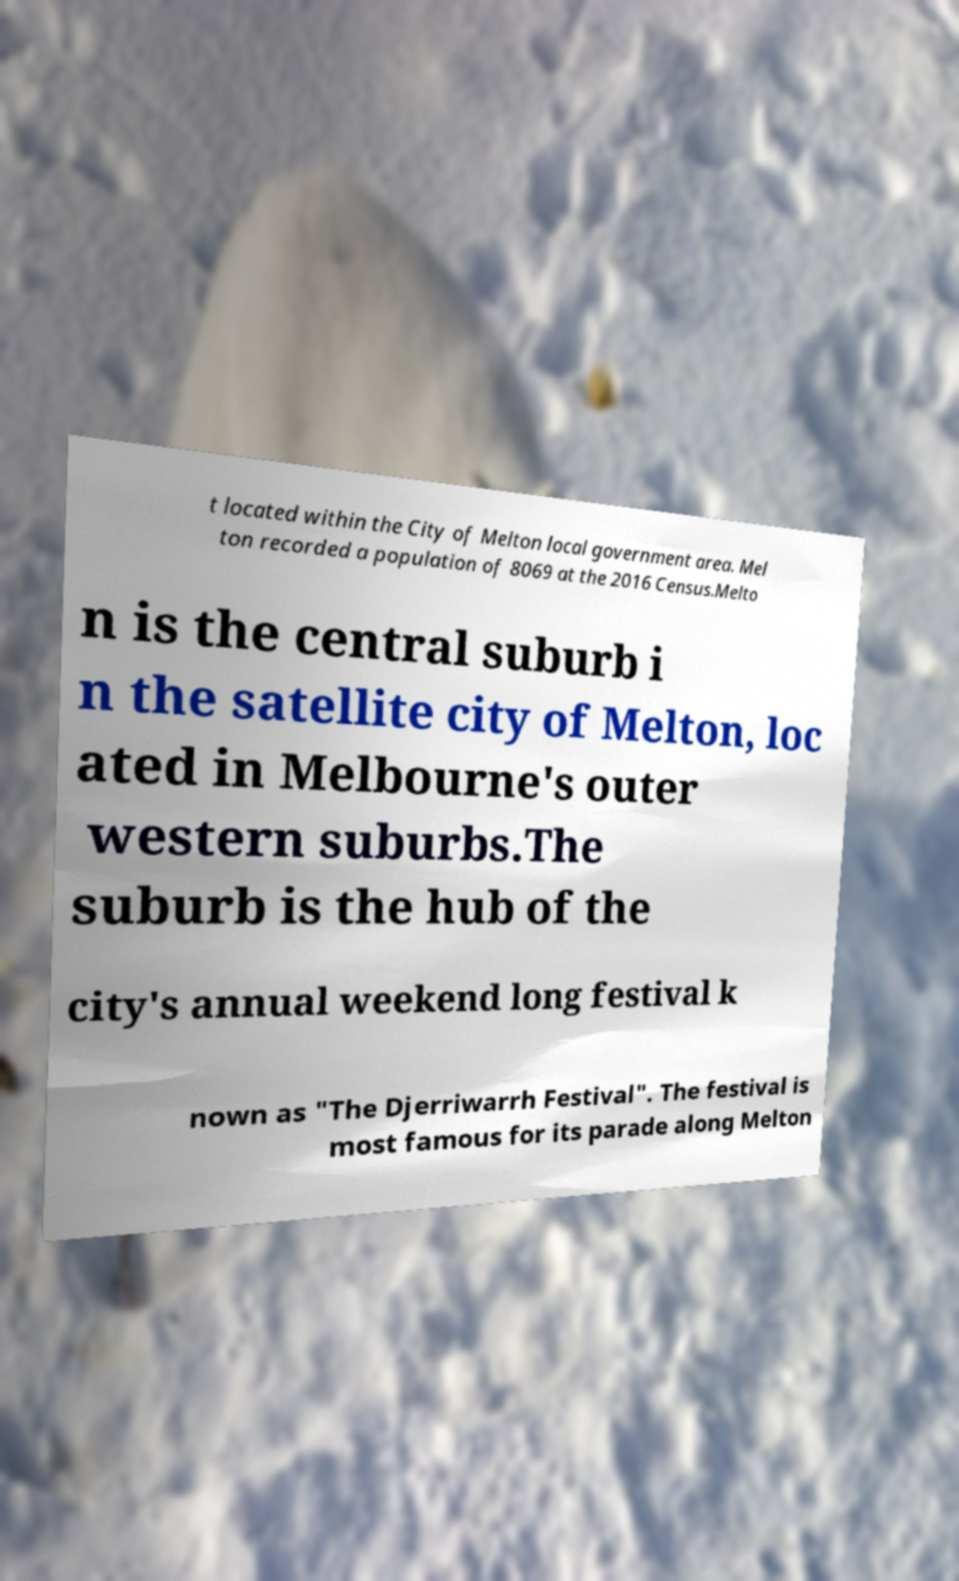Can you read and provide the text displayed in the image?This photo seems to have some interesting text. Can you extract and type it out for me? t located within the City of Melton local government area. Mel ton recorded a population of 8069 at the 2016 Census.Melto n is the central suburb i n the satellite city of Melton, loc ated in Melbourne's outer western suburbs.The suburb is the hub of the city's annual weekend long festival k nown as "The Djerriwarrh Festival". The festival is most famous for its parade along Melton 